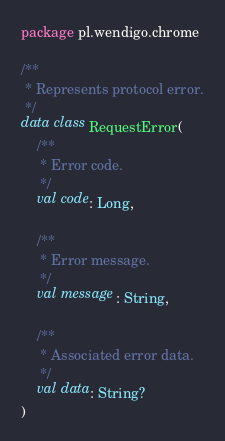<code> <loc_0><loc_0><loc_500><loc_500><_Kotlin_>package pl.wendigo.chrome

/**
 * Represents protocol error.
 */
data class RequestError(
    /**
     * Error code.
     */
    val code: Long,

    /**
     * Error message.
     */
    val message: String,

    /**
     * Associated error data.
     */
    val data: String?
)</code> 